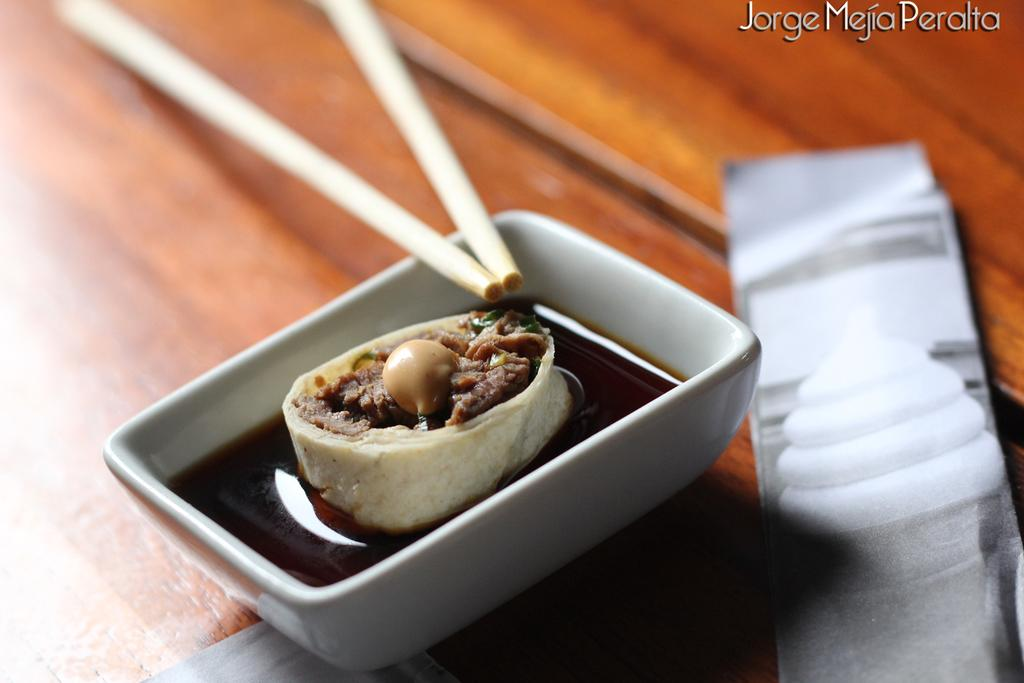What is in the bowl that is visible in the image? There is food in a bowl in the image. What utensil is present in the image? Chopsticks are visible in the image. What type of furniture is in the image? There is a table in the image. Can you see the ocean in the image? No, the ocean is not present in the image. Is there a yak grazing near the table in the image? No, there is no yak present in the image. 